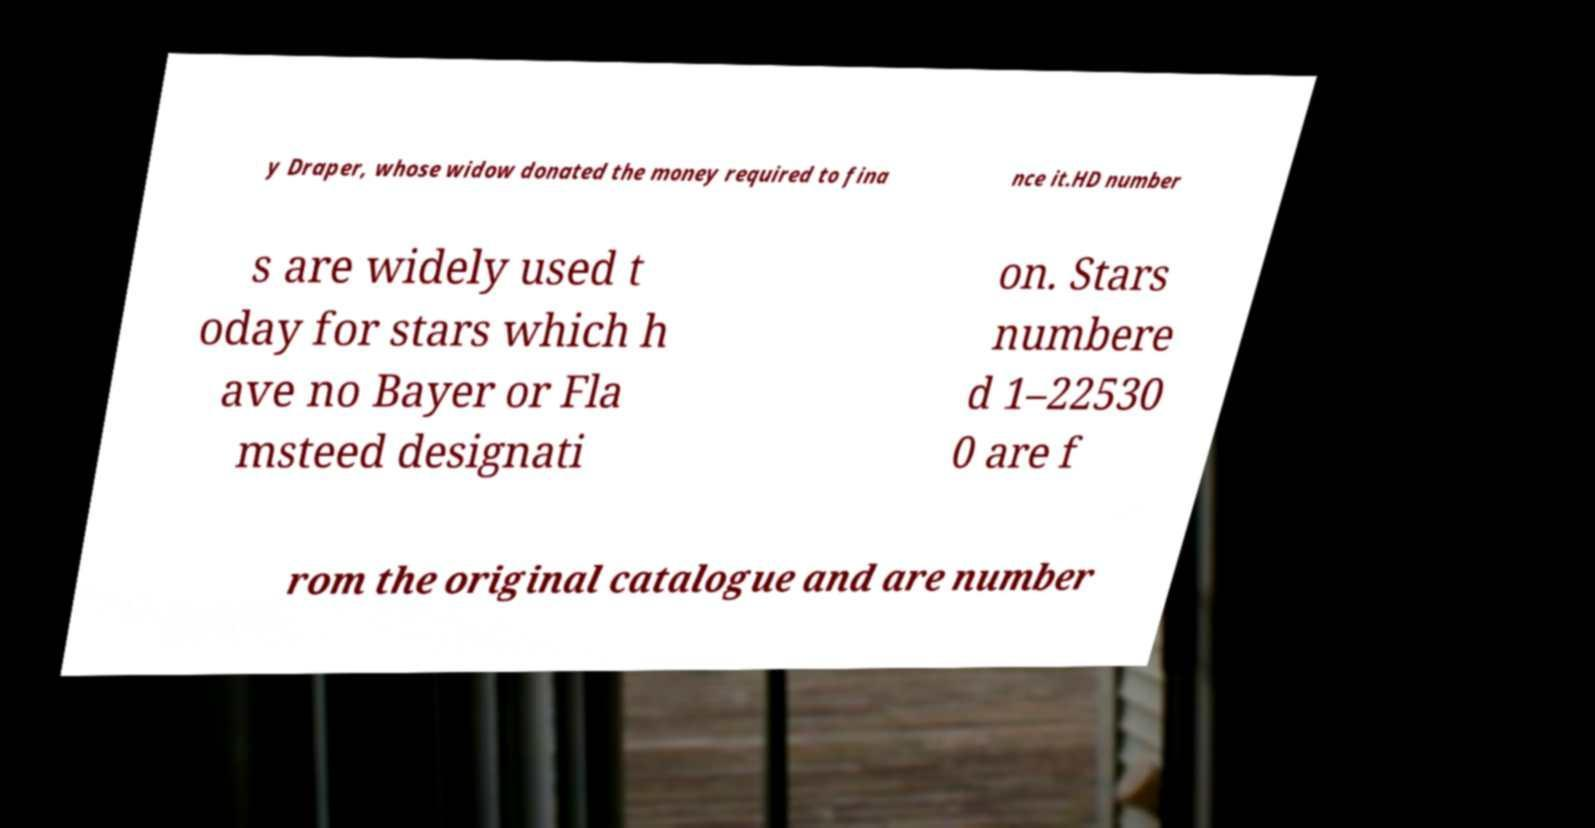Could you extract and type out the text from this image? y Draper, whose widow donated the money required to fina nce it.HD number s are widely used t oday for stars which h ave no Bayer or Fla msteed designati on. Stars numbere d 1–22530 0 are f rom the original catalogue and are number 